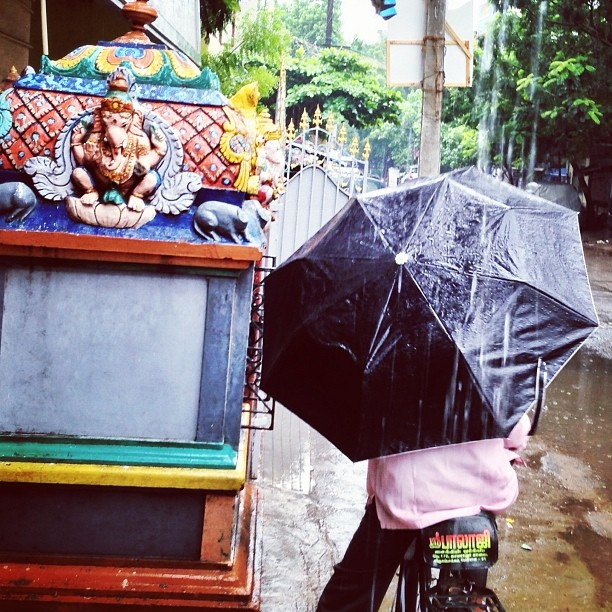Describe the objects in this image and their specific colors. I can see umbrella in maroon, black, lavender, darkgray, and gray tones, people in maroon, lavender, black, pink, and brown tones, bicycle in maroon, black, gray, darkgray, and khaki tones, and bicycle in maroon, black, gray, and darkgray tones in this image. 